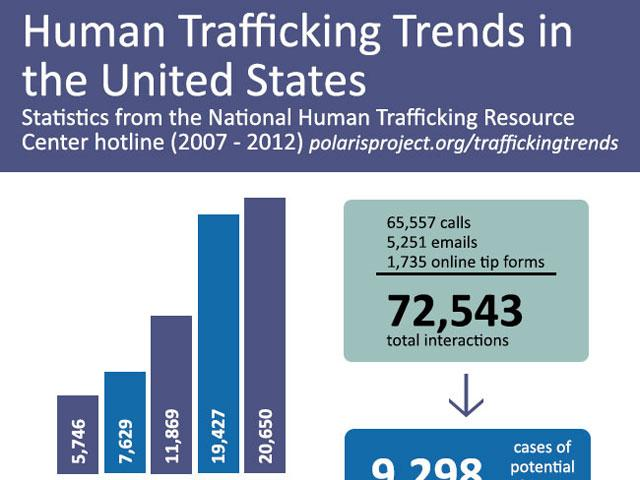Point out several critical features in this image. The largest value in the bar chart is 14904, and the smallest value is 250. In interactions, we will count the number from the lowest online tip form. The second highest number in the bar chart is 19427. There were 70808 emails and calls. 